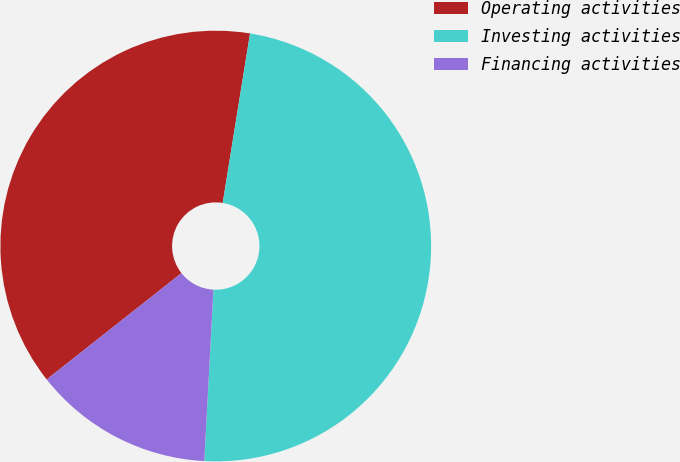Convert chart. <chart><loc_0><loc_0><loc_500><loc_500><pie_chart><fcel>Operating activities<fcel>Investing activities<fcel>Financing activities<nl><fcel>38.18%<fcel>48.31%<fcel>13.52%<nl></chart> 